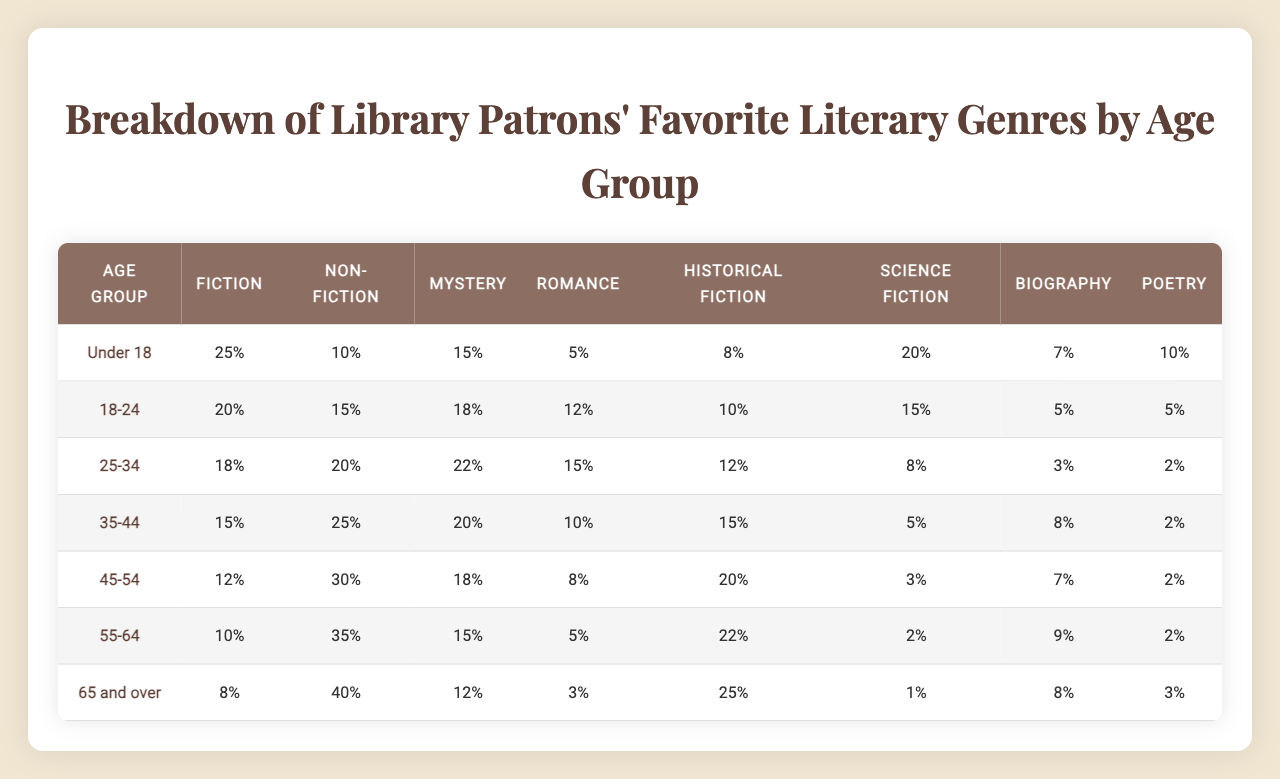What is the favorite literary genre among patrons aged 18-24? Looking at the row for the age group 18-24, the highest percentage is for Non-Fiction at 15%.
Answer: Non-Fiction Which age group has the highest preference for Romance? The highest percentage for Romance is 12%, found in the age group 18-24.
Answer: 18-24 What percentage of patrons aged 65 and over prefer Science Fiction? In the row for the 65 and over age group, the preference for Science Fiction is noted as 1%.
Answer: 1% Which age group shows the greatest interest in Mystery genre? The age group 25-34 has the highest preference for the Mystery genre at 22%.
Answer: 25-34 Is there an age group that prefers Poetry more than 10%? Reviewing the table, the only age group that has a percentage greater than 10% for Poetry is Under 18 at 10%, which is not greater. Therefore, the answer is no.
Answer: No What is the difference in percentage between the highest and lowest preferences for Fiction among the age groups? The highest percentage for Fiction is 25% (Under 18), and the lowest is 8% (65 and over). The difference is 25% - 8% = 17%.
Answer: 17% Which genre has the highest overall preference across all age groups? To determine this, we look for the maximum value in each genre column. Calculating the maximum percentages gives Fiction at 25% (Under 18). Thus, the favorite genre overall is Fiction.
Answer: Fiction Calculate the average percentage preference for Historical Fiction across all age groups. The percentages for Historical Fiction across age groups are 8%, 10%, 12%, 15%, 20%, 22%, and 25%. The sum is (8 + 10 + 12 + 15 + 20 + 22 + 25) = 112. There are 7 age groups, so the average is 112 / 7 = 16%.
Answer: 16% How does the preference for Biography change as the age group increases? Observing the table, the percentages for Biography decrease as age increases: 7%, 5%, 3%, 8%, 7%, 9%, 8%. This indicates a fluctuating but generally declining trend.
Answer: Generally declines Does any age group prefer Non-Fiction more than 35%? Checking the Non-Fiction percentages, the highest is 40% in the 65 and over age group, which is indeed greater than 35%.
Answer: Yes 